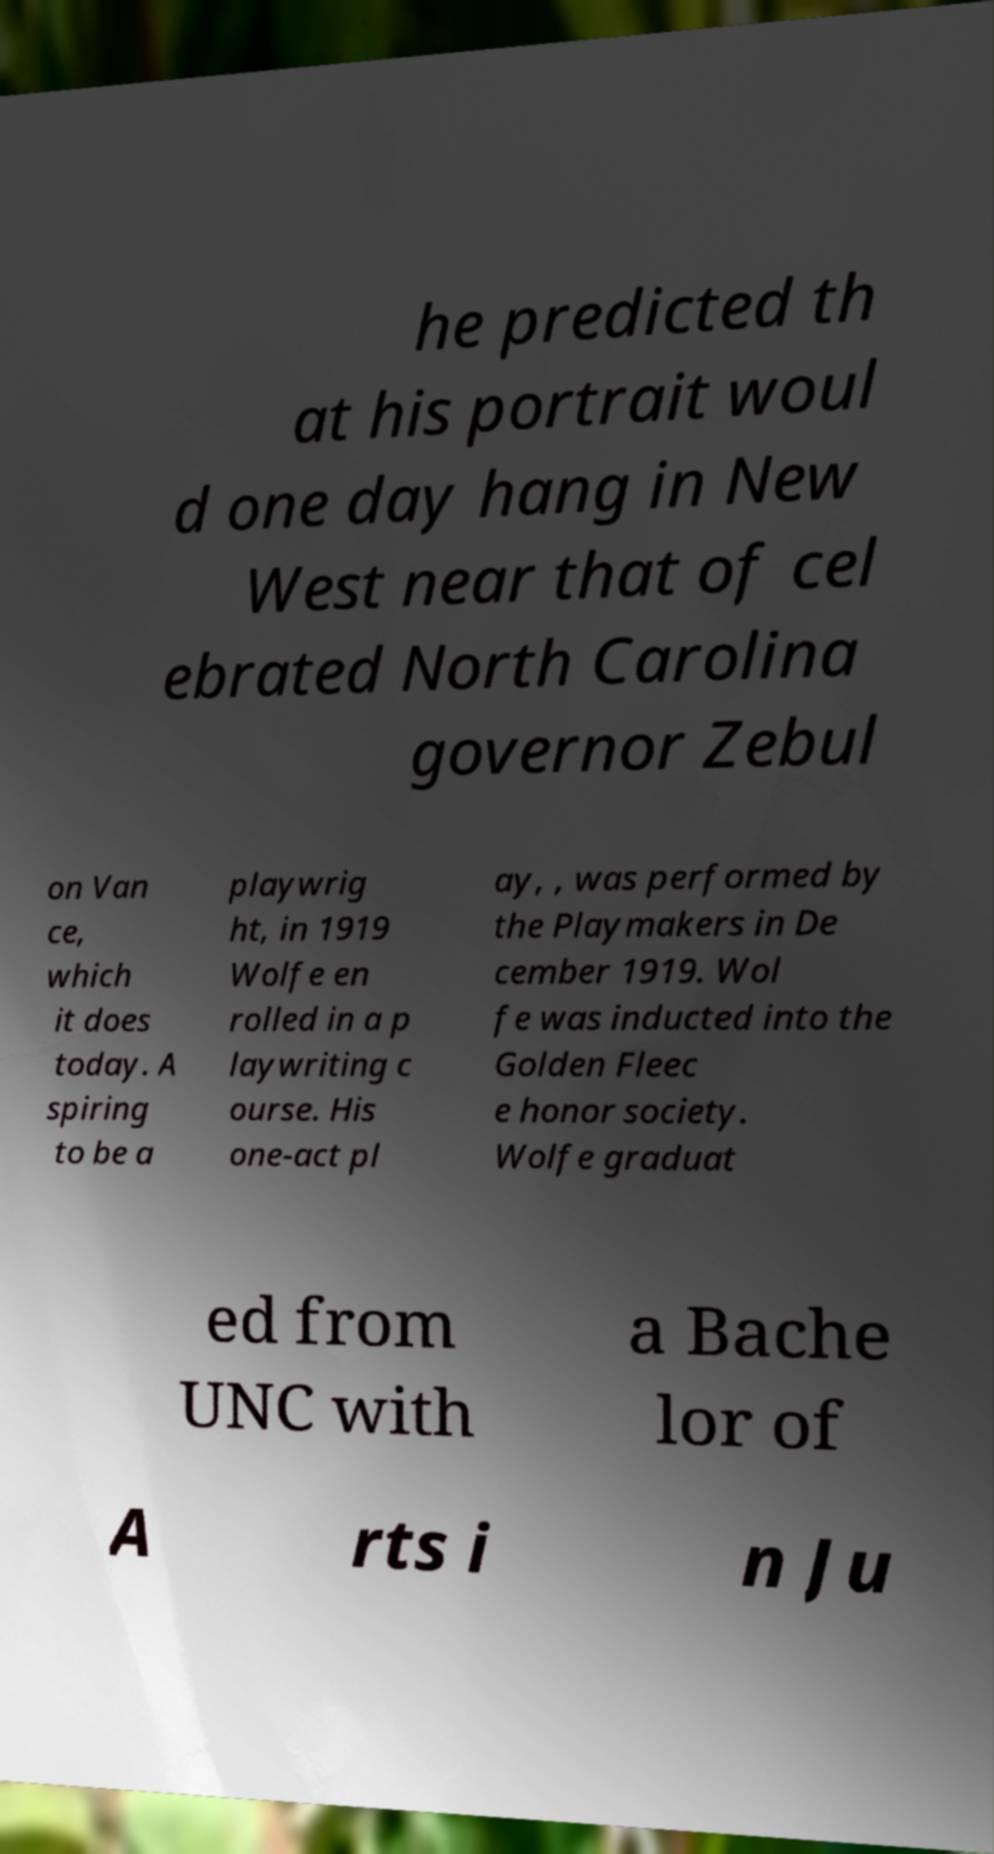Could you assist in decoding the text presented in this image and type it out clearly? he predicted th at his portrait woul d one day hang in New West near that of cel ebrated North Carolina governor Zebul on Van ce, which it does today. A spiring to be a playwrig ht, in 1919 Wolfe en rolled in a p laywriting c ourse. His one-act pl ay, , was performed by the Playmakers in De cember 1919. Wol fe was inducted into the Golden Fleec e honor society. Wolfe graduat ed from UNC with a Bache lor of A rts i n Ju 